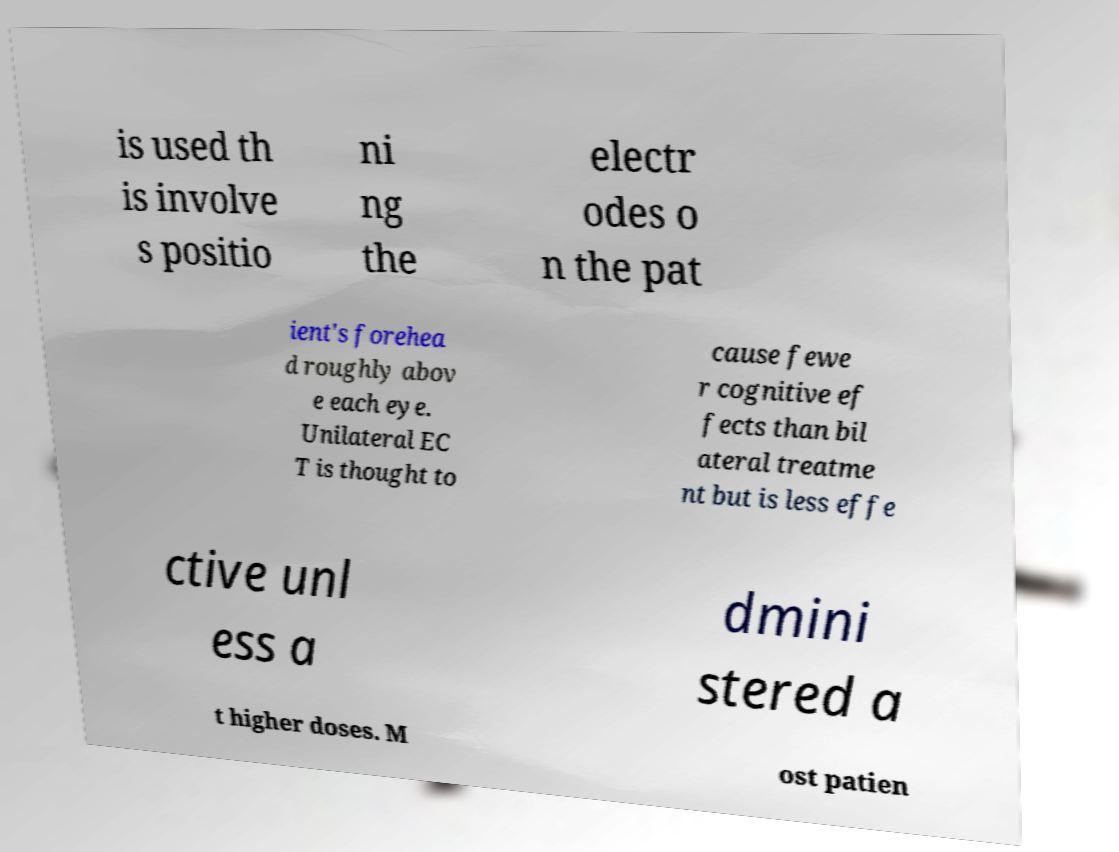I need the written content from this picture converted into text. Can you do that? is used th is involve s positio ni ng the electr odes o n the pat ient's forehea d roughly abov e each eye. Unilateral EC T is thought to cause fewe r cognitive ef fects than bil ateral treatme nt but is less effe ctive unl ess a dmini stered a t higher doses. M ost patien 